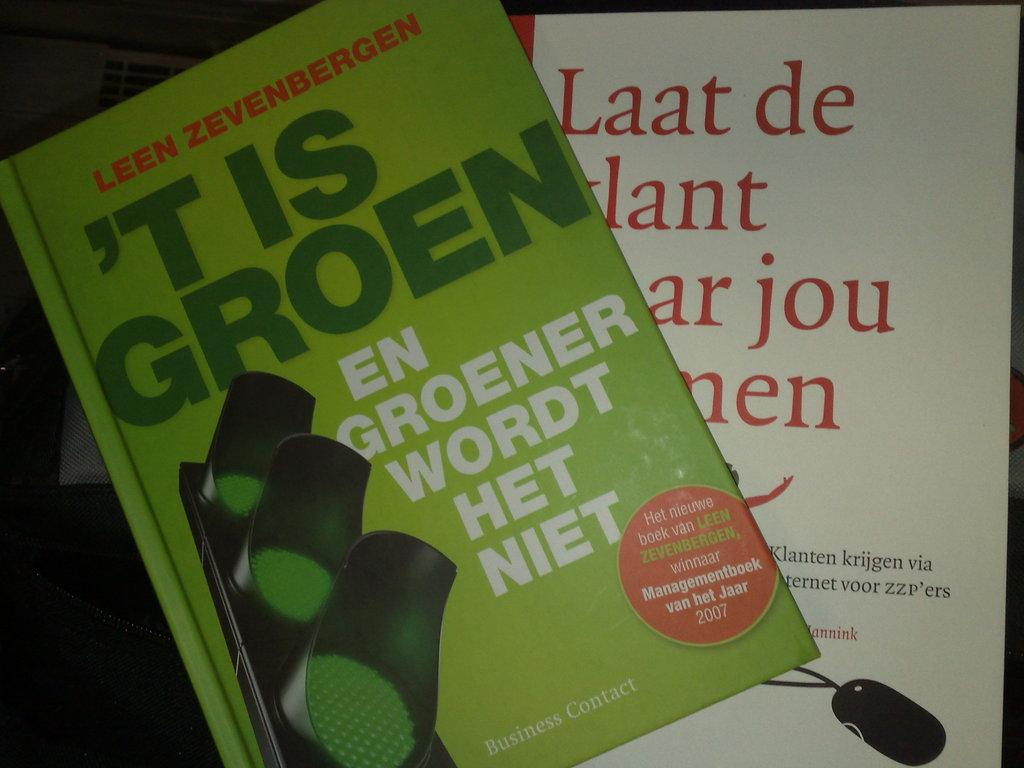<image>
Summarize the visual content of the image. A book by Leen Zevenbergen has a green cover with a traffic light on it. 